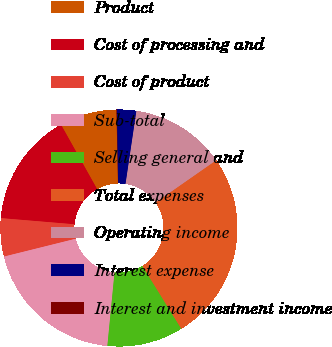<chart> <loc_0><loc_0><loc_500><loc_500><pie_chart><fcel>Product<fcel>Cost of processing and<fcel>Cost of product<fcel>Sub-total<fcel>Selling general and<fcel>Total expenses<fcel>Operating income<fcel>Interest expense<fcel>Interest and investment income<nl><fcel>7.8%<fcel>15.54%<fcel>5.21%<fcel>19.57%<fcel>10.38%<fcel>25.86%<fcel>12.96%<fcel>2.63%<fcel>0.05%<nl></chart> 